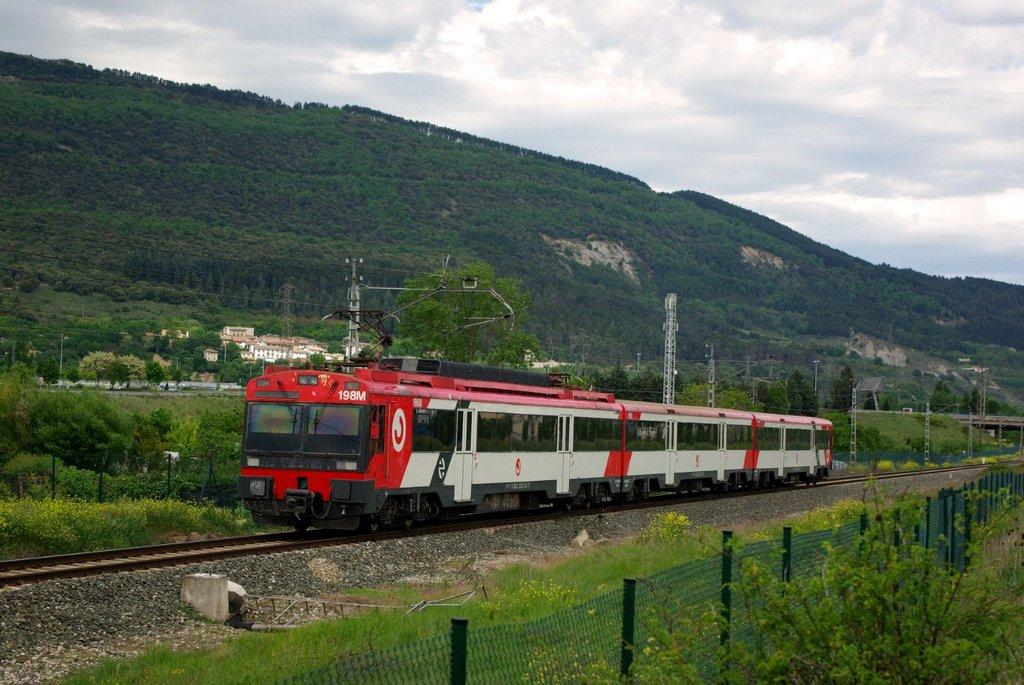What is the main subject of the image? The main subject of the image is a train on a railway track. What can be seen alongside the railway track? There is fencing alongside the railway track. What type of natural elements are present in the image? There are trees and hills visible in the image. What man-made structures can be seen in the image? There are transformers and buildings present in the image. What type of liquid is being used to lubricate the screws on the train in the image? There is no mention of screws or liquid in the image; it features a train on a railway track with surrounding elements. 